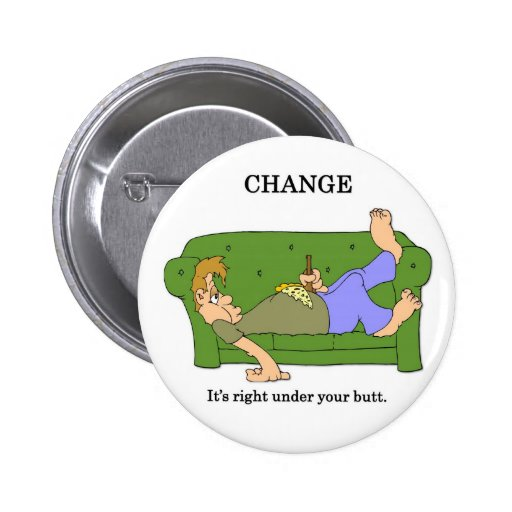If the couch could talk, what advice might it give to the characters? Couch: 'Hey there! You've been lounging around for quite a while. Ever thought about what else you could uncover if you got up and looked around? You'd be surprised at the change you can find, both literally and figuratively. Sometimes all it takes is a little move forward!' 